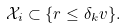<formula> <loc_0><loc_0><loc_500><loc_500>\mathcal { X } _ { i } \subset \{ r \leq \delta _ { k } v \} .</formula> 